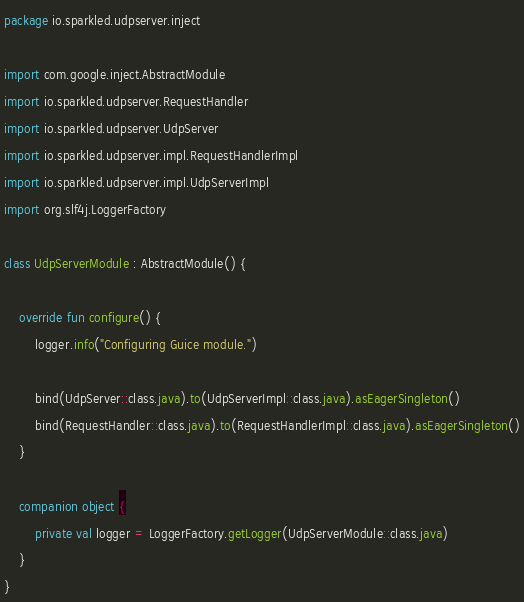Convert code to text. <code><loc_0><loc_0><loc_500><loc_500><_Kotlin_>package io.sparkled.udpserver.inject

import com.google.inject.AbstractModule
import io.sparkled.udpserver.RequestHandler
import io.sparkled.udpserver.UdpServer
import io.sparkled.udpserver.impl.RequestHandlerImpl
import io.sparkled.udpserver.impl.UdpServerImpl
import org.slf4j.LoggerFactory

class UdpServerModule : AbstractModule() {

    override fun configure() {
        logger.info("Configuring Guice module.")

        bind(UdpServer::class.java).to(UdpServerImpl::class.java).asEagerSingleton()
        bind(RequestHandler::class.java).to(RequestHandlerImpl::class.java).asEagerSingleton()
    }

    companion object {
        private val logger = LoggerFactory.getLogger(UdpServerModule::class.java)
    }
}
</code> 